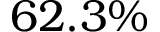Convert formula to latex. <formula><loc_0><loc_0><loc_500><loc_500>6 2 . 3 \%</formula> 